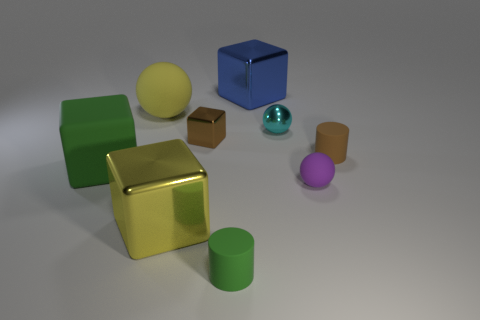There is a tiny thing that is the same color as the tiny cube; what is its shape?
Provide a succinct answer. Cylinder. There is a shiny block that is the same color as the large matte ball; what size is it?
Ensure brevity in your answer.  Large. What is the big yellow thing that is behind the small brown metallic block made of?
Keep it short and to the point. Rubber. How many cylinders have the same color as the small block?
Ensure brevity in your answer.  1. What size is the brown cylinder that is made of the same material as the green block?
Keep it short and to the point. Small. How many things are rubber things or big yellow balls?
Ensure brevity in your answer.  5. The big matte object that is behind the brown metal thing is what color?
Provide a short and direct response. Yellow. There is a purple thing that is the same shape as the large yellow rubber thing; what size is it?
Offer a very short reply. Small. What number of things are small cylinders that are on the right side of the blue block or large cubes that are behind the small brown matte thing?
Provide a succinct answer. 2. What is the size of the rubber object that is both to the right of the tiny cyan shiny object and in front of the big green cube?
Keep it short and to the point. Small. 